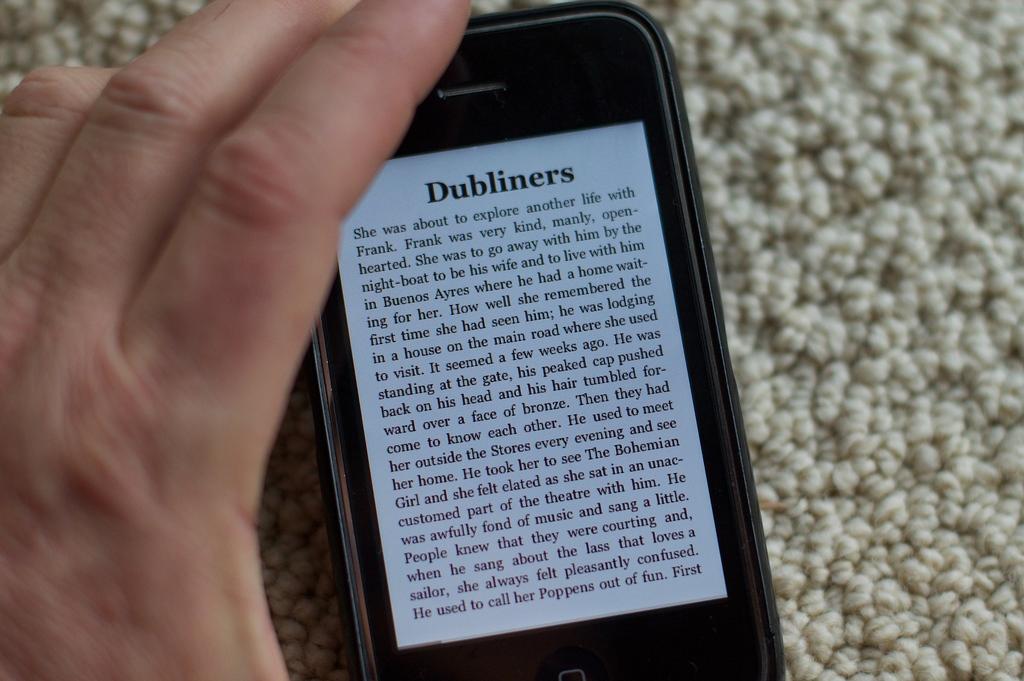What was she about to explore?
Give a very brief answer. Dubliners. What is the title of this text?
Give a very brief answer. Dubliners. 